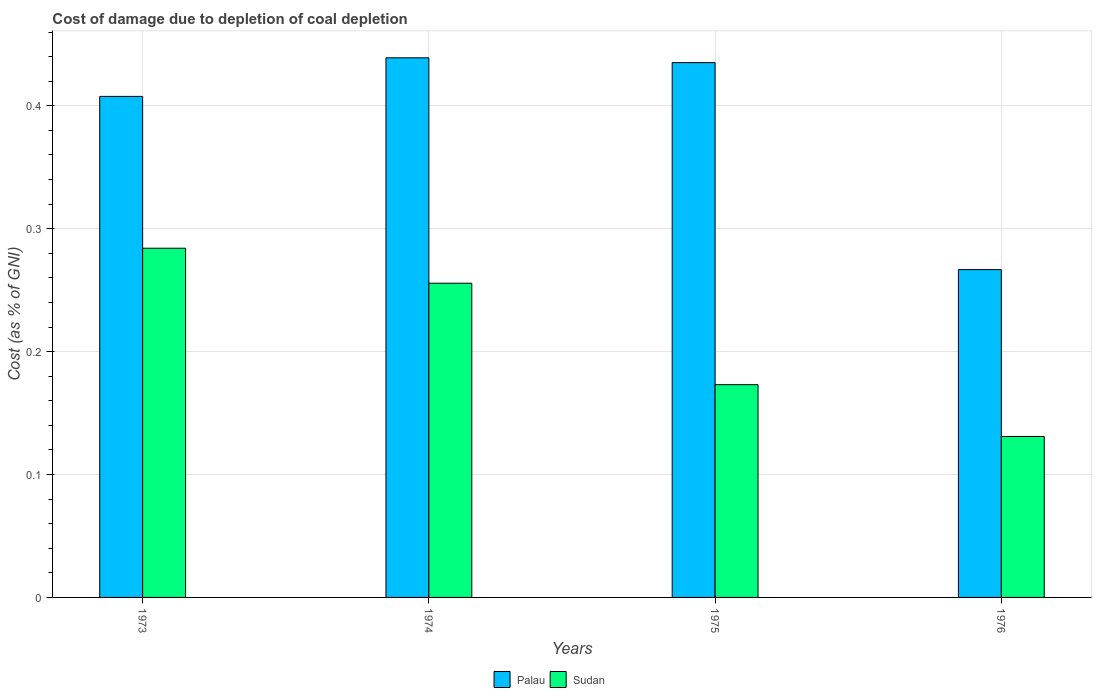How many bars are there on the 2nd tick from the left?
Ensure brevity in your answer.  2. In how many cases, is the number of bars for a given year not equal to the number of legend labels?
Provide a succinct answer. 0. What is the cost of damage caused due to coal depletion in Palau in 1976?
Your response must be concise. 0.27. Across all years, what is the maximum cost of damage caused due to coal depletion in Palau?
Ensure brevity in your answer.  0.44. Across all years, what is the minimum cost of damage caused due to coal depletion in Palau?
Your answer should be very brief. 0.27. In which year was the cost of damage caused due to coal depletion in Sudan maximum?
Offer a very short reply. 1973. In which year was the cost of damage caused due to coal depletion in Sudan minimum?
Provide a succinct answer. 1976. What is the total cost of damage caused due to coal depletion in Palau in the graph?
Give a very brief answer. 1.55. What is the difference between the cost of damage caused due to coal depletion in Palau in 1973 and that in 1974?
Ensure brevity in your answer.  -0.03. What is the difference between the cost of damage caused due to coal depletion in Palau in 1973 and the cost of damage caused due to coal depletion in Sudan in 1976?
Provide a short and direct response. 0.28. What is the average cost of damage caused due to coal depletion in Sudan per year?
Ensure brevity in your answer.  0.21. In the year 1973, what is the difference between the cost of damage caused due to coal depletion in Sudan and cost of damage caused due to coal depletion in Palau?
Ensure brevity in your answer.  -0.12. What is the ratio of the cost of damage caused due to coal depletion in Palau in 1973 to that in 1974?
Your answer should be compact. 0.93. Is the difference between the cost of damage caused due to coal depletion in Sudan in 1974 and 1975 greater than the difference between the cost of damage caused due to coal depletion in Palau in 1974 and 1975?
Ensure brevity in your answer.  Yes. What is the difference between the highest and the second highest cost of damage caused due to coal depletion in Sudan?
Your answer should be compact. 0.03. What is the difference between the highest and the lowest cost of damage caused due to coal depletion in Sudan?
Offer a terse response. 0.15. What does the 1st bar from the left in 1975 represents?
Keep it short and to the point. Palau. What does the 1st bar from the right in 1976 represents?
Offer a terse response. Sudan. How many bars are there?
Provide a succinct answer. 8. Are all the bars in the graph horizontal?
Your answer should be compact. No. Are the values on the major ticks of Y-axis written in scientific E-notation?
Ensure brevity in your answer.  No. Does the graph contain any zero values?
Offer a terse response. No. Does the graph contain grids?
Provide a succinct answer. Yes. Where does the legend appear in the graph?
Give a very brief answer. Bottom center. What is the title of the graph?
Provide a short and direct response. Cost of damage due to depletion of coal depletion. What is the label or title of the X-axis?
Provide a short and direct response. Years. What is the label or title of the Y-axis?
Keep it short and to the point. Cost (as % of GNI). What is the Cost (as % of GNI) of Palau in 1973?
Your response must be concise. 0.41. What is the Cost (as % of GNI) of Sudan in 1973?
Provide a short and direct response. 0.28. What is the Cost (as % of GNI) in Palau in 1974?
Offer a very short reply. 0.44. What is the Cost (as % of GNI) of Sudan in 1974?
Give a very brief answer. 0.26. What is the Cost (as % of GNI) of Palau in 1975?
Keep it short and to the point. 0.44. What is the Cost (as % of GNI) of Sudan in 1975?
Your answer should be compact. 0.17. What is the Cost (as % of GNI) of Palau in 1976?
Provide a short and direct response. 0.27. What is the Cost (as % of GNI) of Sudan in 1976?
Your answer should be very brief. 0.13. Across all years, what is the maximum Cost (as % of GNI) of Palau?
Provide a succinct answer. 0.44. Across all years, what is the maximum Cost (as % of GNI) in Sudan?
Offer a terse response. 0.28. Across all years, what is the minimum Cost (as % of GNI) of Palau?
Provide a short and direct response. 0.27. Across all years, what is the minimum Cost (as % of GNI) of Sudan?
Make the answer very short. 0.13. What is the total Cost (as % of GNI) in Palau in the graph?
Offer a very short reply. 1.55. What is the total Cost (as % of GNI) in Sudan in the graph?
Offer a terse response. 0.84. What is the difference between the Cost (as % of GNI) in Palau in 1973 and that in 1974?
Ensure brevity in your answer.  -0.03. What is the difference between the Cost (as % of GNI) of Sudan in 1973 and that in 1974?
Provide a short and direct response. 0.03. What is the difference between the Cost (as % of GNI) in Palau in 1973 and that in 1975?
Your answer should be compact. -0.03. What is the difference between the Cost (as % of GNI) of Sudan in 1973 and that in 1975?
Give a very brief answer. 0.11. What is the difference between the Cost (as % of GNI) in Palau in 1973 and that in 1976?
Your answer should be very brief. 0.14. What is the difference between the Cost (as % of GNI) in Sudan in 1973 and that in 1976?
Offer a terse response. 0.15. What is the difference between the Cost (as % of GNI) in Palau in 1974 and that in 1975?
Offer a terse response. 0. What is the difference between the Cost (as % of GNI) in Sudan in 1974 and that in 1975?
Keep it short and to the point. 0.08. What is the difference between the Cost (as % of GNI) in Palau in 1974 and that in 1976?
Ensure brevity in your answer.  0.17. What is the difference between the Cost (as % of GNI) in Sudan in 1974 and that in 1976?
Provide a short and direct response. 0.12. What is the difference between the Cost (as % of GNI) of Palau in 1975 and that in 1976?
Ensure brevity in your answer.  0.17. What is the difference between the Cost (as % of GNI) in Sudan in 1975 and that in 1976?
Give a very brief answer. 0.04. What is the difference between the Cost (as % of GNI) in Palau in 1973 and the Cost (as % of GNI) in Sudan in 1974?
Give a very brief answer. 0.15. What is the difference between the Cost (as % of GNI) of Palau in 1973 and the Cost (as % of GNI) of Sudan in 1975?
Give a very brief answer. 0.23. What is the difference between the Cost (as % of GNI) in Palau in 1973 and the Cost (as % of GNI) in Sudan in 1976?
Give a very brief answer. 0.28. What is the difference between the Cost (as % of GNI) in Palau in 1974 and the Cost (as % of GNI) in Sudan in 1975?
Provide a succinct answer. 0.27. What is the difference between the Cost (as % of GNI) of Palau in 1974 and the Cost (as % of GNI) of Sudan in 1976?
Your response must be concise. 0.31. What is the difference between the Cost (as % of GNI) of Palau in 1975 and the Cost (as % of GNI) of Sudan in 1976?
Your response must be concise. 0.3. What is the average Cost (as % of GNI) of Palau per year?
Your answer should be very brief. 0.39. What is the average Cost (as % of GNI) of Sudan per year?
Make the answer very short. 0.21. In the year 1973, what is the difference between the Cost (as % of GNI) in Palau and Cost (as % of GNI) in Sudan?
Provide a short and direct response. 0.12. In the year 1974, what is the difference between the Cost (as % of GNI) in Palau and Cost (as % of GNI) in Sudan?
Provide a short and direct response. 0.18. In the year 1975, what is the difference between the Cost (as % of GNI) in Palau and Cost (as % of GNI) in Sudan?
Give a very brief answer. 0.26. In the year 1976, what is the difference between the Cost (as % of GNI) in Palau and Cost (as % of GNI) in Sudan?
Provide a succinct answer. 0.14. What is the ratio of the Cost (as % of GNI) of Palau in 1973 to that in 1974?
Offer a very short reply. 0.93. What is the ratio of the Cost (as % of GNI) of Sudan in 1973 to that in 1974?
Offer a very short reply. 1.11. What is the ratio of the Cost (as % of GNI) of Palau in 1973 to that in 1975?
Keep it short and to the point. 0.94. What is the ratio of the Cost (as % of GNI) in Sudan in 1973 to that in 1975?
Keep it short and to the point. 1.64. What is the ratio of the Cost (as % of GNI) of Palau in 1973 to that in 1976?
Keep it short and to the point. 1.53. What is the ratio of the Cost (as % of GNI) of Sudan in 1973 to that in 1976?
Provide a succinct answer. 2.17. What is the ratio of the Cost (as % of GNI) of Sudan in 1974 to that in 1975?
Offer a very short reply. 1.48. What is the ratio of the Cost (as % of GNI) in Palau in 1974 to that in 1976?
Provide a succinct answer. 1.65. What is the ratio of the Cost (as % of GNI) of Sudan in 1974 to that in 1976?
Your response must be concise. 1.95. What is the ratio of the Cost (as % of GNI) of Palau in 1975 to that in 1976?
Offer a very short reply. 1.63. What is the ratio of the Cost (as % of GNI) in Sudan in 1975 to that in 1976?
Offer a very short reply. 1.32. What is the difference between the highest and the second highest Cost (as % of GNI) of Palau?
Keep it short and to the point. 0. What is the difference between the highest and the second highest Cost (as % of GNI) in Sudan?
Keep it short and to the point. 0.03. What is the difference between the highest and the lowest Cost (as % of GNI) in Palau?
Provide a short and direct response. 0.17. What is the difference between the highest and the lowest Cost (as % of GNI) of Sudan?
Make the answer very short. 0.15. 